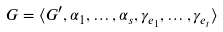<formula> <loc_0><loc_0><loc_500><loc_500>G = \langle G ^ { \prime } , \alpha _ { 1 } , \dots , \alpha _ { s } , \gamma _ { e _ { 1 } } , \dots , \gamma _ { e _ { t } } \rangle</formula> 